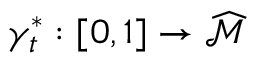<formula> <loc_0><loc_0><loc_500><loc_500>\gamma _ { t } ^ { * } \colon [ 0 , 1 ] \rightarrow \widehat { \mathcal { M } }</formula> 